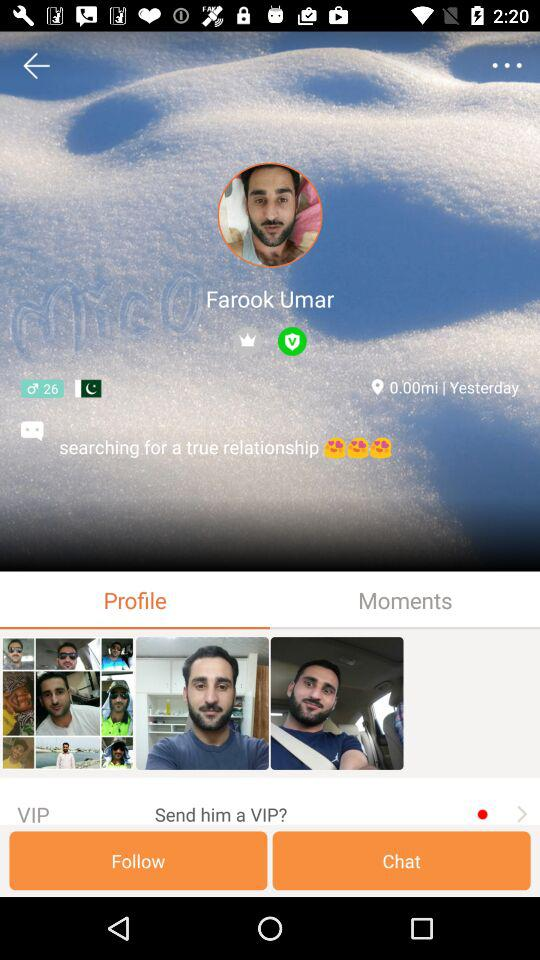How many smiley faces are there?
Answer the question using a single word or phrase. 3 